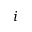<formula> <loc_0><loc_0><loc_500><loc_500>i</formula> 